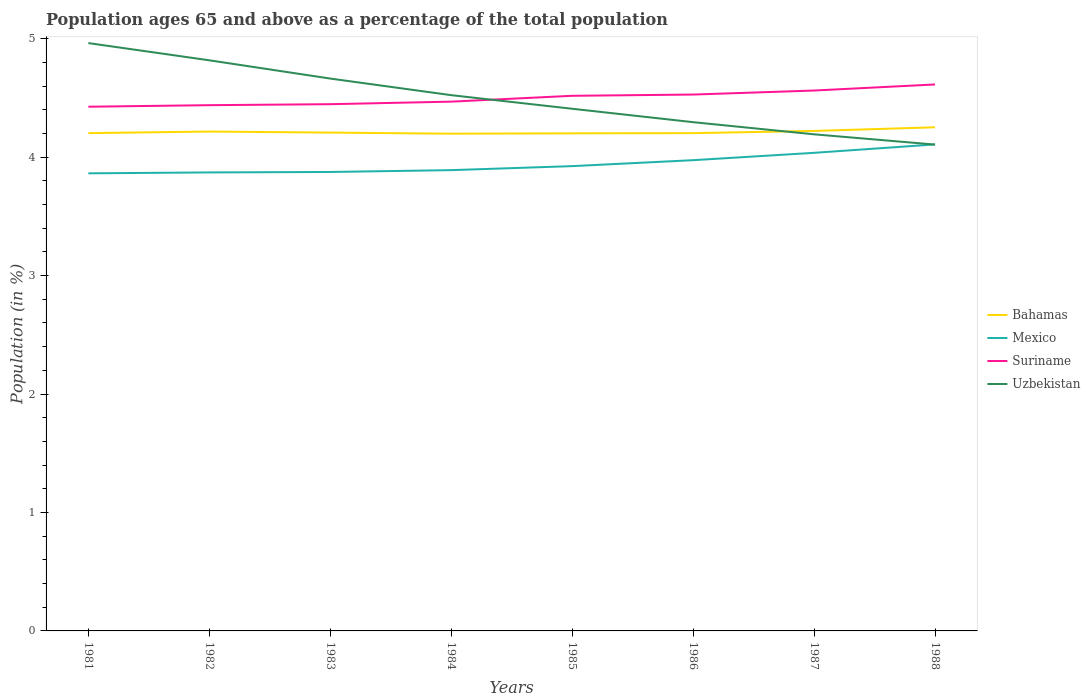How many different coloured lines are there?
Offer a very short reply. 4. Across all years, what is the maximum percentage of the population ages 65 and above in Uzbekistan?
Make the answer very short. 4.11. What is the total percentage of the population ages 65 and above in Uzbekistan in the graph?
Offer a very short reply. 0.71. What is the difference between the highest and the second highest percentage of the population ages 65 and above in Bahamas?
Your answer should be very brief. 0.05. What is the difference between the highest and the lowest percentage of the population ages 65 and above in Uzbekistan?
Keep it short and to the point. 4. Is the percentage of the population ages 65 and above in Bahamas strictly greater than the percentage of the population ages 65 and above in Uzbekistan over the years?
Your answer should be compact. No. How many lines are there?
Ensure brevity in your answer.  4. How many years are there in the graph?
Provide a succinct answer. 8. Does the graph contain any zero values?
Keep it short and to the point. No. Where does the legend appear in the graph?
Make the answer very short. Center right. How are the legend labels stacked?
Provide a succinct answer. Vertical. What is the title of the graph?
Offer a very short reply. Population ages 65 and above as a percentage of the total population. What is the label or title of the X-axis?
Provide a short and direct response. Years. What is the Population (in %) in Bahamas in 1981?
Your response must be concise. 4.2. What is the Population (in %) in Mexico in 1981?
Ensure brevity in your answer.  3.86. What is the Population (in %) in Suriname in 1981?
Offer a very short reply. 4.43. What is the Population (in %) of Uzbekistan in 1981?
Provide a short and direct response. 4.96. What is the Population (in %) in Bahamas in 1982?
Provide a short and direct response. 4.22. What is the Population (in %) of Mexico in 1982?
Offer a terse response. 3.87. What is the Population (in %) of Suriname in 1982?
Your answer should be compact. 4.44. What is the Population (in %) in Uzbekistan in 1982?
Offer a terse response. 4.82. What is the Population (in %) of Bahamas in 1983?
Provide a short and direct response. 4.21. What is the Population (in %) in Mexico in 1983?
Make the answer very short. 3.87. What is the Population (in %) in Suriname in 1983?
Your answer should be compact. 4.45. What is the Population (in %) in Uzbekistan in 1983?
Offer a terse response. 4.66. What is the Population (in %) in Bahamas in 1984?
Keep it short and to the point. 4.2. What is the Population (in %) of Mexico in 1984?
Offer a terse response. 3.89. What is the Population (in %) of Suriname in 1984?
Offer a very short reply. 4.47. What is the Population (in %) in Uzbekistan in 1984?
Keep it short and to the point. 4.52. What is the Population (in %) in Bahamas in 1985?
Provide a succinct answer. 4.2. What is the Population (in %) of Mexico in 1985?
Your response must be concise. 3.92. What is the Population (in %) in Suriname in 1985?
Ensure brevity in your answer.  4.52. What is the Population (in %) of Uzbekistan in 1985?
Make the answer very short. 4.41. What is the Population (in %) in Bahamas in 1986?
Your response must be concise. 4.2. What is the Population (in %) in Mexico in 1986?
Your answer should be very brief. 3.97. What is the Population (in %) of Suriname in 1986?
Your answer should be very brief. 4.53. What is the Population (in %) of Uzbekistan in 1986?
Make the answer very short. 4.29. What is the Population (in %) of Bahamas in 1987?
Offer a terse response. 4.22. What is the Population (in %) in Mexico in 1987?
Offer a very short reply. 4.04. What is the Population (in %) in Suriname in 1987?
Provide a short and direct response. 4.56. What is the Population (in %) in Uzbekistan in 1987?
Your answer should be very brief. 4.19. What is the Population (in %) of Bahamas in 1988?
Offer a terse response. 4.25. What is the Population (in %) in Mexico in 1988?
Provide a succinct answer. 4.11. What is the Population (in %) in Suriname in 1988?
Provide a succinct answer. 4.61. What is the Population (in %) of Uzbekistan in 1988?
Make the answer very short. 4.11. Across all years, what is the maximum Population (in %) in Bahamas?
Provide a succinct answer. 4.25. Across all years, what is the maximum Population (in %) of Mexico?
Provide a succinct answer. 4.11. Across all years, what is the maximum Population (in %) of Suriname?
Make the answer very short. 4.61. Across all years, what is the maximum Population (in %) in Uzbekistan?
Give a very brief answer. 4.96. Across all years, what is the minimum Population (in %) in Bahamas?
Give a very brief answer. 4.2. Across all years, what is the minimum Population (in %) of Mexico?
Offer a very short reply. 3.86. Across all years, what is the minimum Population (in %) in Suriname?
Offer a terse response. 4.43. Across all years, what is the minimum Population (in %) of Uzbekistan?
Offer a very short reply. 4.11. What is the total Population (in %) of Bahamas in the graph?
Your answer should be compact. 33.7. What is the total Population (in %) in Mexico in the graph?
Ensure brevity in your answer.  31.54. What is the total Population (in %) in Suriname in the graph?
Ensure brevity in your answer.  36. What is the total Population (in %) of Uzbekistan in the graph?
Your answer should be compact. 35.97. What is the difference between the Population (in %) in Bahamas in 1981 and that in 1982?
Give a very brief answer. -0.01. What is the difference between the Population (in %) in Mexico in 1981 and that in 1982?
Provide a succinct answer. -0.01. What is the difference between the Population (in %) in Suriname in 1981 and that in 1982?
Your answer should be very brief. -0.01. What is the difference between the Population (in %) in Uzbekistan in 1981 and that in 1982?
Your answer should be compact. 0.15. What is the difference between the Population (in %) of Bahamas in 1981 and that in 1983?
Your answer should be very brief. -0. What is the difference between the Population (in %) in Mexico in 1981 and that in 1983?
Make the answer very short. -0.01. What is the difference between the Population (in %) in Suriname in 1981 and that in 1983?
Ensure brevity in your answer.  -0.02. What is the difference between the Population (in %) of Uzbekistan in 1981 and that in 1983?
Your answer should be very brief. 0.3. What is the difference between the Population (in %) of Bahamas in 1981 and that in 1984?
Offer a terse response. 0. What is the difference between the Population (in %) in Mexico in 1981 and that in 1984?
Your response must be concise. -0.03. What is the difference between the Population (in %) in Suriname in 1981 and that in 1984?
Offer a very short reply. -0.04. What is the difference between the Population (in %) in Uzbekistan in 1981 and that in 1984?
Offer a terse response. 0.44. What is the difference between the Population (in %) of Bahamas in 1981 and that in 1985?
Offer a very short reply. 0. What is the difference between the Population (in %) in Mexico in 1981 and that in 1985?
Offer a very short reply. -0.06. What is the difference between the Population (in %) in Suriname in 1981 and that in 1985?
Your answer should be compact. -0.09. What is the difference between the Population (in %) in Uzbekistan in 1981 and that in 1985?
Provide a short and direct response. 0.55. What is the difference between the Population (in %) of Mexico in 1981 and that in 1986?
Offer a terse response. -0.11. What is the difference between the Population (in %) of Suriname in 1981 and that in 1986?
Keep it short and to the point. -0.1. What is the difference between the Population (in %) in Uzbekistan in 1981 and that in 1986?
Provide a short and direct response. 0.67. What is the difference between the Population (in %) of Bahamas in 1981 and that in 1987?
Keep it short and to the point. -0.02. What is the difference between the Population (in %) of Mexico in 1981 and that in 1987?
Keep it short and to the point. -0.17. What is the difference between the Population (in %) of Suriname in 1981 and that in 1987?
Your answer should be compact. -0.14. What is the difference between the Population (in %) in Uzbekistan in 1981 and that in 1987?
Your answer should be very brief. 0.77. What is the difference between the Population (in %) in Bahamas in 1981 and that in 1988?
Your answer should be compact. -0.05. What is the difference between the Population (in %) in Mexico in 1981 and that in 1988?
Your response must be concise. -0.24. What is the difference between the Population (in %) of Suriname in 1981 and that in 1988?
Ensure brevity in your answer.  -0.19. What is the difference between the Population (in %) in Uzbekistan in 1981 and that in 1988?
Provide a short and direct response. 0.86. What is the difference between the Population (in %) in Bahamas in 1982 and that in 1983?
Give a very brief answer. 0.01. What is the difference between the Population (in %) of Mexico in 1982 and that in 1983?
Ensure brevity in your answer.  -0. What is the difference between the Population (in %) of Suriname in 1982 and that in 1983?
Your response must be concise. -0.01. What is the difference between the Population (in %) of Uzbekistan in 1982 and that in 1983?
Offer a terse response. 0.15. What is the difference between the Population (in %) of Bahamas in 1982 and that in 1984?
Offer a terse response. 0.02. What is the difference between the Population (in %) of Mexico in 1982 and that in 1984?
Give a very brief answer. -0.02. What is the difference between the Population (in %) of Suriname in 1982 and that in 1984?
Your answer should be compact. -0.03. What is the difference between the Population (in %) of Uzbekistan in 1982 and that in 1984?
Offer a terse response. 0.29. What is the difference between the Population (in %) of Bahamas in 1982 and that in 1985?
Give a very brief answer. 0.02. What is the difference between the Population (in %) of Mexico in 1982 and that in 1985?
Give a very brief answer. -0.05. What is the difference between the Population (in %) of Suriname in 1982 and that in 1985?
Offer a terse response. -0.08. What is the difference between the Population (in %) in Uzbekistan in 1982 and that in 1985?
Your response must be concise. 0.41. What is the difference between the Population (in %) in Bahamas in 1982 and that in 1986?
Make the answer very short. 0.01. What is the difference between the Population (in %) in Mexico in 1982 and that in 1986?
Provide a succinct answer. -0.1. What is the difference between the Population (in %) in Suriname in 1982 and that in 1986?
Provide a short and direct response. -0.09. What is the difference between the Population (in %) of Uzbekistan in 1982 and that in 1986?
Your answer should be very brief. 0.52. What is the difference between the Population (in %) of Bahamas in 1982 and that in 1987?
Your answer should be very brief. -0.01. What is the difference between the Population (in %) in Mexico in 1982 and that in 1987?
Offer a very short reply. -0.17. What is the difference between the Population (in %) in Suriname in 1982 and that in 1987?
Your answer should be compact. -0.12. What is the difference between the Population (in %) in Uzbekistan in 1982 and that in 1987?
Your answer should be compact. 0.62. What is the difference between the Population (in %) in Bahamas in 1982 and that in 1988?
Your answer should be compact. -0.04. What is the difference between the Population (in %) of Mexico in 1982 and that in 1988?
Your response must be concise. -0.24. What is the difference between the Population (in %) of Suriname in 1982 and that in 1988?
Provide a succinct answer. -0.17. What is the difference between the Population (in %) of Uzbekistan in 1982 and that in 1988?
Ensure brevity in your answer.  0.71. What is the difference between the Population (in %) of Bahamas in 1983 and that in 1984?
Your answer should be compact. 0.01. What is the difference between the Population (in %) of Mexico in 1983 and that in 1984?
Offer a very short reply. -0.02. What is the difference between the Population (in %) of Suriname in 1983 and that in 1984?
Your answer should be very brief. -0.02. What is the difference between the Population (in %) in Uzbekistan in 1983 and that in 1984?
Offer a terse response. 0.14. What is the difference between the Population (in %) in Bahamas in 1983 and that in 1985?
Make the answer very short. 0.01. What is the difference between the Population (in %) in Mexico in 1983 and that in 1985?
Your response must be concise. -0.05. What is the difference between the Population (in %) of Suriname in 1983 and that in 1985?
Offer a terse response. -0.07. What is the difference between the Population (in %) of Uzbekistan in 1983 and that in 1985?
Your answer should be very brief. 0.25. What is the difference between the Population (in %) in Bahamas in 1983 and that in 1986?
Give a very brief answer. 0. What is the difference between the Population (in %) of Mexico in 1983 and that in 1986?
Your answer should be compact. -0.1. What is the difference between the Population (in %) of Suriname in 1983 and that in 1986?
Provide a succinct answer. -0.08. What is the difference between the Population (in %) of Uzbekistan in 1983 and that in 1986?
Provide a short and direct response. 0.37. What is the difference between the Population (in %) in Bahamas in 1983 and that in 1987?
Your response must be concise. -0.01. What is the difference between the Population (in %) in Mexico in 1983 and that in 1987?
Give a very brief answer. -0.16. What is the difference between the Population (in %) in Suriname in 1983 and that in 1987?
Give a very brief answer. -0.12. What is the difference between the Population (in %) in Uzbekistan in 1983 and that in 1987?
Offer a terse response. 0.47. What is the difference between the Population (in %) of Bahamas in 1983 and that in 1988?
Make the answer very short. -0.04. What is the difference between the Population (in %) of Mexico in 1983 and that in 1988?
Make the answer very short. -0.23. What is the difference between the Population (in %) in Suriname in 1983 and that in 1988?
Give a very brief answer. -0.17. What is the difference between the Population (in %) in Uzbekistan in 1983 and that in 1988?
Your answer should be compact. 0.56. What is the difference between the Population (in %) in Bahamas in 1984 and that in 1985?
Provide a succinct answer. -0. What is the difference between the Population (in %) of Mexico in 1984 and that in 1985?
Provide a short and direct response. -0.03. What is the difference between the Population (in %) of Suriname in 1984 and that in 1985?
Your answer should be compact. -0.05. What is the difference between the Population (in %) of Uzbekistan in 1984 and that in 1985?
Your answer should be compact. 0.11. What is the difference between the Population (in %) in Bahamas in 1984 and that in 1986?
Provide a succinct answer. -0. What is the difference between the Population (in %) in Mexico in 1984 and that in 1986?
Your response must be concise. -0.08. What is the difference between the Population (in %) of Suriname in 1984 and that in 1986?
Your response must be concise. -0.06. What is the difference between the Population (in %) in Uzbekistan in 1984 and that in 1986?
Offer a terse response. 0.23. What is the difference between the Population (in %) in Bahamas in 1984 and that in 1987?
Make the answer very short. -0.02. What is the difference between the Population (in %) of Mexico in 1984 and that in 1987?
Keep it short and to the point. -0.15. What is the difference between the Population (in %) of Suriname in 1984 and that in 1987?
Provide a short and direct response. -0.09. What is the difference between the Population (in %) in Uzbekistan in 1984 and that in 1987?
Provide a succinct answer. 0.33. What is the difference between the Population (in %) in Bahamas in 1984 and that in 1988?
Offer a very short reply. -0.05. What is the difference between the Population (in %) of Mexico in 1984 and that in 1988?
Provide a short and direct response. -0.22. What is the difference between the Population (in %) of Suriname in 1984 and that in 1988?
Provide a succinct answer. -0.15. What is the difference between the Population (in %) in Uzbekistan in 1984 and that in 1988?
Offer a very short reply. 0.42. What is the difference between the Population (in %) of Bahamas in 1985 and that in 1986?
Your answer should be very brief. -0. What is the difference between the Population (in %) of Mexico in 1985 and that in 1986?
Your answer should be very brief. -0.05. What is the difference between the Population (in %) of Suriname in 1985 and that in 1986?
Your response must be concise. -0.01. What is the difference between the Population (in %) in Uzbekistan in 1985 and that in 1986?
Offer a terse response. 0.11. What is the difference between the Population (in %) in Bahamas in 1985 and that in 1987?
Your response must be concise. -0.02. What is the difference between the Population (in %) in Mexico in 1985 and that in 1987?
Offer a terse response. -0.11. What is the difference between the Population (in %) in Suriname in 1985 and that in 1987?
Your response must be concise. -0.04. What is the difference between the Population (in %) in Uzbekistan in 1985 and that in 1987?
Offer a terse response. 0.22. What is the difference between the Population (in %) in Bahamas in 1985 and that in 1988?
Provide a short and direct response. -0.05. What is the difference between the Population (in %) in Mexico in 1985 and that in 1988?
Your answer should be very brief. -0.18. What is the difference between the Population (in %) of Suriname in 1985 and that in 1988?
Your answer should be compact. -0.1. What is the difference between the Population (in %) in Uzbekistan in 1985 and that in 1988?
Your response must be concise. 0.3. What is the difference between the Population (in %) in Bahamas in 1986 and that in 1987?
Ensure brevity in your answer.  -0.02. What is the difference between the Population (in %) in Mexico in 1986 and that in 1987?
Provide a succinct answer. -0.06. What is the difference between the Population (in %) of Suriname in 1986 and that in 1987?
Your answer should be compact. -0.03. What is the difference between the Population (in %) of Uzbekistan in 1986 and that in 1987?
Your answer should be compact. 0.1. What is the difference between the Population (in %) of Bahamas in 1986 and that in 1988?
Provide a short and direct response. -0.05. What is the difference between the Population (in %) in Mexico in 1986 and that in 1988?
Keep it short and to the point. -0.13. What is the difference between the Population (in %) of Suriname in 1986 and that in 1988?
Offer a terse response. -0.09. What is the difference between the Population (in %) in Uzbekistan in 1986 and that in 1988?
Provide a short and direct response. 0.19. What is the difference between the Population (in %) in Bahamas in 1987 and that in 1988?
Provide a short and direct response. -0.03. What is the difference between the Population (in %) in Mexico in 1987 and that in 1988?
Keep it short and to the point. -0.07. What is the difference between the Population (in %) in Suriname in 1987 and that in 1988?
Your answer should be very brief. -0.05. What is the difference between the Population (in %) of Uzbekistan in 1987 and that in 1988?
Provide a short and direct response. 0.09. What is the difference between the Population (in %) in Bahamas in 1981 and the Population (in %) in Mexico in 1982?
Offer a very short reply. 0.33. What is the difference between the Population (in %) in Bahamas in 1981 and the Population (in %) in Suriname in 1982?
Make the answer very short. -0.24. What is the difference between the Population (in %) of Bahamas in 1981 and the Population (in %) of Uzbekistan in 1982?
Offer a terse response. -0.61. What is the difference between the Population (in %) of Mexico in 1981 and the Population (in %) of Suriname in 1982?
Offer a very short reply. -0.58. What is the difference between the Population (in %) in Mexico in 1981 and the Population (in %) in Uzbekistan in 1982?
Offer a very short reply. -0.95. What is the difference between the Population (in %) of Suriname in 1981 and the Population (in %) of Uzbekistan in 1982?
Your response must be concise. -0.39. What is the difference between the Population (in %) in Bahamas in 1981 and the Population (in %) in Mexico in 1983?
Give a very brief answer. 0.33. What is the difference between the Population (in %) in Bahamas in 1981 and the Population (in %) in Suriname in 1983?
Your response must be concise. -0.24. What is the difference between the Population (in %) of Bahamas in 1981 and the Population (in %) of Uzbekistan in 1983?
Ensure brevity in your answer.  -0.46. What is the difference between the Population (in %) in Mexico in 1981 and the Population (in %) in Suriname in 1983?
Provide a short and direct response. -0.58. What is the difference between the Population (in %) of Mexico in 1981 and the Population (in %) of Uzbekistan in 1983?
Your answer should be very brief. -0.8. What is the difference between the Population (in %) in Suriname in 1981 and the Population (in %) in Uzbekistan in 1983?
Make the answer very short. -0.24. What is the difference between the Population (in %) in Bahamas in 1981 and the Population (in %) in Mexico in 1984?
Provide a succinct answer. 0.31. What is the difference between the Population (in %) in Bahamas in 1981 and the Population (in %) in Suriname in 1984?
Provide a succinct answer. -0.27. What is the difference between the Population (in %) in Bahamas in 1981 and the Population (in %) in Uzbekistan in 1984?
Your response must be concise. -0.32. What is the difference between the Population (in %) of Mexico in 1981 and the Population (in %) of Suriname in 1984?
Ensure brevity in your answer.  -0.61. What is the difference between the Population (in %) in Mexico in 1981 and the Population (in %) in Uzbekistan in 1984?
Provide a succinct answer. -0.66. What is the difference between the Population (in %) in Suriname in 1981 and the Population (in %) in Uzbekistan in 1984?
Your response must be concise. -0.1. What is the difference between the Population (in %) of Bahamas in 1981 and the Population (in %) of Mexico in 1985?
Provide a short and direct response. 0.28. What is the difference between the Population (in %) of Bahamas in 1981 and the Population (in %) of Suriname in 1985?
Give a very brief answer. -0.32. What is the difference between the Population (in %) in Bahamas in 1981 and the Population (in %) in Uzbekistan in 1985?
Ensure brevity in your answer.  -0.21. What is the difference between the Population (in %) of Mexico in 1981 and the Population (in %) of Suriname in 1985?
Provide a short and direct response. -0.65. What is the difference between the Population (in %) in Mexico in 1981 and the Population (in %) in Uzbekistan in 1985?
Give a very brief answer. -0.55. What is the difference between the Population (in %) in Suriname in 1981 and the Population (in %) in Uzbekistan in 1985?
Make the answer very short. 0.02. What is the difference between the Population (in %) of Bahamas in 1981 and the Population (in %) of Mexico in 1986?
Make the answer very short. 0.23. What is the difference between the Population (in %) of Bahamas in 1981 and the Population (in %) of Suriname in 1986?
Ensure brevity in your answer.  -0.33. What is the difference between the Population (in %) in Bahamas in 1981 and the Population (in %) in Uzbekistan in 1986?
Your response must be concise. -0.09. What is the difference between the Population (in %) in Mexico in 1981 and the Population (in %) in Suriname in 1986?
Offer a terse response. -0.67. What is the difference between the Population (in %) in Mexico in 1981 and the Population (in %) in Uzbekistan in 1986?
Offer a very short reply. -0.43. What is the difference between the Population (in %) of Suriname in 1981 and the Population (in %) of Uzbekistan in 1986?
Offer a terse response. 0.13. What is the difference between the Population (in %) of Bahamas in 1981 and the Population (in %) of Mexico in 1987?
Provide a short and direct response. 0.17. What is the difference between the Population (in %) in Bahamas in 1981 and the Population (in %) in Suriname in 1987?
Offer a very short reply. -0.36. What is the difference between the Population (in %) in Bahamas in 1981 and the Population (in %) in Uzbekistan in 1987?
Your answer should be compact. 0.01. What is the difference between the Population (in %) of Mexico in 1981 and the Population (in %) of Suriname in 1987?
Make the answer very short. -0.7. What is the difference between the Population (in %) in Mexico in 1981 and the Population (in %) in Uzbekistan in 1987?
Your response must be concise. -0.33. What is the difference between the Population (in %) of Suriname in 1981 and the Population (in %) of Uzbekistan in 1987?
Your answer should be very brief. 0.23. What is the difference between the Population (in %) of Bahamas in 1981 and the Population (in %) of Mexico in 1988?
Your response must be concise. 0.1. What is the difference between the Population (in %) in Bahamas in 1981 and the Population (in %) in Suriname in 1988?
Keep it short and to the point. -0.41. What is the difference between the Population (in %) of Bahamas in 1981 and the Population (in %) of Uzbekistan in 1988?
Keep it short and to the point. 0.1. What is the difference between the Population (in %) in Mexico in 1981 and the Population (in %) in Suriname in 1988?
Your answer should be compact. -0.75. What is the difference between the Population (in %) of Mexico in 1981 and the Population (in %) of Uzbekistan in 1988?
Keep it short and to the point. -0.24. What is the difference between the Population (in %) in Suriname in 1981 and the Population (in %) in Uzbekistan in 1988?
Offer a very short reply. 0.32. What is the difference between the Population (in %) of Bahamas in 1982 and the Population (in %) of Mexico in 1983?
Provide a succinct answer. 0.34. What is the difference between the Population (in %) in Bahamas in 1982 and the Population (in %) in Suriname in 1983?
Provide a short and direct response. -0.23. What is the difference between the Population (in %) of Bahamas in 1982 and the Population (in %) of Uzbekistan in 1983?
Offer a very short reply. -0.45. What is the difference between the Population (in %) in Mexico in 1982 and the Population (in %) in Suriname in 1983?
Your response must be concise. -0.58. What is the difference between the Population (in %) of Mexico in 1982 and the Population (in %) of Uzbekistan in 1983?
Your answer should be compact. -0.79. What is the difference between the Population (in %) in Suriname in 1982 and the Population (in %) in Uzbekistan in 1983?
Offer a very short reply. -0.22. What is the difference between the Population (in %) in Bahamas in 1982 and the Population (in %) in Mexico in 1984?
Your answer should be very brief. 0.33. What is the difference between the Population (in %) of Bahamas in 1982 and the Population (in %) of Suriname in 1984?
Ensure brevity in your answer.  -0.25. What is the difference between the Population (in %) of Bahamas in 1982 and the Population (in %) of Uzbekistan in 1984?
Provide a short and direct response. -0.31. What is the difference between the Population (in %) in Mexico in 1982 and the Population (in %) in Suriname in 1984?
Ensure brevity in your answer.  -0.6. What is the difference between the Population (in %) of Mexico in 1982 and the Population (in %) of Uzbekistan in 1984?
Offer a terse response. -0.65. What is the difference between the Population (in %) in Suriname in 1982 and the Population (in %) in Uzbekistan in 1984?
Give a very brief answer. -0.08. What is the difference between the Population (in %) in Bahamas in 1982 and the Population (in %) in Mexico in 1985?
Give a very brief answer. 0.29. What is the difference between the Population (in %) of Bahamas in 1982 and the Population (in %) of Suriname in 1985?
Ensure brevity in your answer.  -0.3. What is the difference between the Population (in %) in Bahamas in 1982 and the Population (in %) in Uzbekistan in 1985?
Offer a very short reply. -0.19. What is the difference between the Population (in %) in Mexico in 1982 and the Population (in %) in Suriname in 1985?
Provide a short and direct response. -0.65. What is the difference between the Population (in %) of Mexico in 1982 and the Population (in %) of Uzbekistan in 1985?
Offer a very short reply. -0.54. What is the difference between the Population (in %) of Suriname in 1982 and the Population (in %) of Uzbekistan in 1985?
Make the answer very short. 0.03. What is the difference between the Population (in %) of Bahamas in 1982 and the Population (in %) of Mexico in 1986?
Offer a very short reply. 0.24. What is the difference between the Population (in %) in Bahamas in 1982 and the Population (in %) in Suriname in 1986?
Offer a very short reply. -0.31. What is the difference between the Population (in %) of Bahamas in 1982 and the Population (in %) of Uzbekistan in 1986?
Give a very brief answer. -0.08. What is the difference between the Population (in %) in Mexico in 1982 and the Population (in %) in Suriname in 1986?
Give a very brief answer. -0.66. What is the difference between the Population (in %) in Mexico in 1982 and the Population (in %) in Uzbekistan in 1986?
Offer a very short reply. -0.42. What is the difference between the Population (in %) in Suriname in 1982 and the Population (in %) in Uzbekistan in 1986?
Provide a succinct answer. 0.14. What is the difference between the Population (in %) in Bahamas in 1982 and the Population (in %) in Mexico in 1987?
Provide a short and direct response. 0.18. What is the difference between the Population (in %) of Bahamas in 1982 and the Population (in %) of Suriname in 1987?
Your response must be concise. -0.35. What is the difference between the Population (in %) in Bahamas in 1982 and the Population (in %) in Uzbekistan in 1987?
Ensure brevity in your answer.  0.02. What is the difference between the Population (in %) in Mexico in 1982 and the Population (in %) in Suriname in 1987?
Offer a terse response. -0.69. What is the difference between the Population (in %) in Mexico in 1982 and the Population (in %) in Uzbekistan in 1987?
Offer a terse response. -0.32. What is the difference between the Population (in %) of Suriname in 1982 and the Population (in %) of Uzbekistan in 1987?
Make the answer very short. 0.25. What is the difference between the Population (in %) of Bahamas in 1982 and the Population (in %) of Mexico in 1988?
Give a very brief answer. 0.11. What is the difference between the Population (in %) of Bahamas in 1982 and the Population (in %) of Suriname in 1988?
Make the answer very short. -0.4. What is the difference between the Population (in %) in Bahamas in 1982 and the Population (in %) in Uzbekistan in 1988?
Your answer should be compact. 0.11. What is the difference between the Population (in %) of Mexico in 1982 and the Population (in %) of Suriname in 1988?
Your answer should be compact. -0.74. What is the difference between the Population (in %) in Mexico in 1982 and the Population (in %) in Uzbekistan in 1988?
Provide a short and direct response. -0.23. What is the difference between the Population (in %) in Suriname in 1982 and the Population (in %) in Uzbekistan in 1988?
Make the answer very short. 0.33. What is the difference between the Population (in %) of Bahamas in 1983 and the Population (in %) of Mexico in 1984?
Ensure brevity in your answer.  0.32. What is the difference between the Population (in %) in Bahamas in 1983 and the Population (in %) in Suriname in 1984?
Keep it short and to the point. -0.26. What is the difference between the Population (in %) in Bahamas in 1983 and the Population (in %) in Uzbekistan in 1984?
Ensure brevity in your answer.  -0.32. What is the difference between the Population (in %) in Mexico in 1983 and the Population (in %) in Suriname in 1984?
Your response must be concise. -0.59. What is the difference between the Population (in %) of Mexico in 1983 and the Population (in %) of Uzbekistan in 1984?
Ensure brevity in your answer.  -0.65. What is the difference between the Population (in %) of Suriname in 1983 and the Population (in %) of Uzbekistan in 1984?
Your answer should be compact. -0.08. What is the difference between the Population (in %) in Bahamas in 1983 and the Population (in %) in Mexico in 1985?
Provide a short and direct response. 0.28. What is the difference between the Population (in %) of Bahamas in 1983 and the Population (in %) of Suriname in 1985?
Offer a very short reply. -0.31. What is the difference between the Population (in %) in Bahamas in 1983 and the Population (in %) in Uzbekistan in 1985?
Give a very brief answer. -0.2. What is the difference between the Population (in %) of Mexico in 1983 and the Population (in %) of Suriname in 1985?
Offer a terse response. -0.64. What is the difference between the Population (in %) of Mexico in 1983 and the Population (in %) of Uzbekistan in 1985?
Your response must be concise. -0.53. What is the difference between the Population (in %) in Suriname in 1983 and the Population (in %) in Uzbekistan in 1985?
Provide a succinct answer. 0.04. What is the difference between the Population (in %) of Bahamas in 1983 and the Population (in %) of Mexico in 1986?
Your answer should be compact. 0.23. What is the difference between the Population (in %) in Bahamas in 1983 and the Population (in %) in Suriname in 1986?
Your answer should be compact. -0.32. What is the difference between the Population (in %) of Bahamas in 1983 and the Population (in %) of Uzbekistan in 1986?
Make the answer very short. -0.09. What is the difference between the Population (in %) in Mexico in 1983 and the Population (in %) in Suriname in 1986?
Your response must be concise. -0.65. What is the difference between the Population (in %) in Mexico in 1983 and the Population (in %) in Uzbekistan in 1986?
Give a very brief answer. -0.42. What is the difference between the Population (in %) in Suriname in 1983 and the Population (in %) in Uzbekistan in 1986?
Your response must be concise. 0.15. What is the difference between the Population (in %) in Bahamas in 1983 and the Population (in %) in Mexico in 1987?
Your answer should be compact. 0.17. What is the difference between the Population (in %) in Bahamas in 1983 and the Population (in %) in Suriname in 1987?
Give a very brief answer. -0.36. What is the difference between the Population (in %) in Bahamas in 1983 and the Population (in %) in Uzbekistan in 1987?
Offer a very short reply. 0.01. What is the difference between the Population (in %) of Mexico in 1983 and the Population (in %) of Suriname in 1987?
Offer a terse response. -0.69. What is the difference between the Population (in %) in Mexico in 1983 and the Population (in %) in Uzbekistan in 1987?
Ensure brevity in your answer.  -0.32. What is the difference between the Population (in %) in Suriname in 1983 and the Population (in %) in Uzbekistan in 1987?
Make the answer very short. 0.25. What is the difference between the Population (in %) of Bahamas in 1983 and the Population (in %) of Mexico in 1988?
Offer a very short reply. 0.1. What is the difference between the Population (in %) of Bahamas in 1983 and the Population (in %) of Suriname in 1988?
Give a very brief answer. -0.41. What is the difference between the Population (in %) in Bahamas in 1983 and the Population (in %) in Uzbekistan in 1988?
Offer a very short reply. 0.1. What is the difference between the Population (in %) of Mexico in 1983 and the Population (in %) of Suriname in 1988?
Your response must be concise. -0.74. What is the difference between the Population (in %) of Mexico in 1983 and the Population (in %) of Uzbekistan in 1988?
Give a very brief answer. -0.23. What is the difference between the Population (in %) of Suriname in 1983 and the Population (in %) of Uzbekistan in 1988?
Your response must be concise. 0.34. What is the difference between the Population (in %) of Bahamas in 1984 and the Population (in %) of Mexico in 1985?
Your answer should be very brief. 0.27. What is the difference between the Population (in %) in Bahamas in 1984 and the Population (in %) in Suriname in 1985?
Keep it short and to the point. -0.32. What is the difference between the Population (in %) in Bahamas in 1984 and the Population (in %) in Uzbekistan in 1985?
Ensure brevity in your answer.  -0.21. What is the difference between the Population (in %) of Mexico in 1984 and the Population (in %) of Suriname in 1985?
Your response must be concise. -0.63. What is the difference between the Population (in %) of Mexico in 1984 and the Population (in %) of Uzbekistan in 1985?
Keep it short and to the point. -0.52. What is the difference between the Population (in %) of Suriname in 1984 and the Population (in %) of Uzbekistan in 1985?
Ensure brevity in your answer.  0.06. What is the difference between the Population (in %) in Bahamas in 1984 and the Population (in %) in Mexico in 1986?
Give a very brief answer. 0.22. What is the difference between the Population (in %) in Bahamas in 1984 and the Population (in %) in Suriname in 1986?
Offer a terse response. -0.33. What is the difference between the Population (in %) in Bahamas in 1984 and the Population (in %) in Uzbekistan in 1986?
Keep it short and to the point. -0.1. What is the difference between the Population (in %) in Mexico in 1984 and the Population (in %) in Suriname in 1986?
Your answer should be compact. -0.64. What is the difference between the Population (in %) of Mexico in 1984 and the Population (in %) of Uzbekistan in 1986?
Keep it short and to the point. -0.41. What is the difference between the Population (in %) of Suriname in 1984 and the Population (in %) of Uzbekistan in 1986?
Provide a succinct answer. 0.17. What is the difference between the Population (in %) of Bahamas in 1984 and the Population (in %) of Mexico in 1987?
Ensure brevity in your answer.  0.16. What is the difference between the Population (in %) in Bahamas in 1984 and the Population (in %) in Suriname in 1987?
Your response must be concise. -0.36. What is the difference between the Population (in %) in Bahamas in 1984 and the Population (in %) in Uzbekistan in 1987?
Your answer should be very brief. 0.01. What is the difference between the Population (in %) in Mexico in 1984 and the Population (in %) in Suriname in 1987?
Your answer should be compact. -0.67. What is the difference between the Population (in %) in Mexico in 1984 and the Population (in %) in Uzbekistan in 1987?
Your response must be concise. -0.3. What is the difference between the Population (in %) in Suriname in 1984 and the Population (in %) in Uzbekistan in 1987?
Give a very brief answer. 0.28. What is the difference between the Population (in %) in Bahamas in 1984 and the Population (in %) in Mexico in 1988?
Provide a succinct answer. 0.09. What is the difference between the Population (in %) in Bahamas in 1984 and the Population (in %) in Suriname in 1988?
Offer a terse response. -0.42. What is the difference between the Population (in %) in Bahamas in 1984 and the Population (in %) in Uzbekistan in 1988?
Offer a very short reply. 0.09. What is the difference between the Population (in %) of Mexico in 1984 and the Population (in %) of Suriname in 1988?
Keep it short and to the point. -0.72. What is the difference between the Population (in %) of Mexico in 1984 and the Population (in %) of Uzbekistan in 1988?
Your answer should be compact. -0.22. What is the difference between the Population (in %) of Suriname in 1984 and the Population (in %) of Uzbekistan in 1988?
Keep it short and to the point. 0.36. What is the difference between the Population (in %) in Bahamas in 1985 and the Population (in %) in Mexico in 1986?
Ensure brevity in your answer.  0.23. What is the difference between the Population (in %) in Bahamas in 1985 and the Population (in %) in Suriname in 1986?
Offer a terse response. -0.33. What is the difference between the Population (in %) in Bahamas in 1985 and the Population (in %) in Uzbekistan in 1986?
Offer a very short reply. -0.09. What is the difference between the Population (in %) in Mexico in 1985 and the Population (in %) in Suriname in 1986?
Your response must be concise. -0.6. What is the difference between the Population (in %) of Mexico in 1985 and the Population (in %) of Uzbekistan in 1986?
Your response must be concise. -0.37. What is the difference between the Population (in %) of Suriname in 1985 and the Population (in %) of Uzbekistan in 1986?
Your answer should be very brief. 0.22. What is the difference between the Population (in %) in Bahamas in 1985 and the Population (in %) in Mexico in 1987?
Your answer should be compact. 0.16. What is the difference between the Population (in %) of Bahamas in 1985 and the Population (in %) of Suriname in 1987?
Make the answer very short. -0.36. What is the difference between the Population (in %) of Bahamas in 1985 and the Population (in %) of Uzbekistan in 1987?
Your answer should be compact. 0.01. What is the difference between the Population (in %) in Mexico in 1985 and the Population (in %) in Suriname in 1987?
Your response must be concise. -0.64. What is the difference between the Population (in %) of Mexico in 1985 and the Population (in %) of Uzbekistan in 1987?
Offer a terse response. -0.27. What is the difference between the Population (in %) of Suriname in 1985 and the Population (in %) of Uzbekistan in 1987?
Offer a very short reply. 0.33. What is the difference between the Population (in %) in Bahamas in 1985 and the Population (in %) in Mexico in 1988?
Offer a terse response. 0.09. What is the difference between the Population (in %) in Bahamas in 1985 and the Population (in %) in Suriname in 1988?
Provide a short and direct response. -0.41. What is the difference between the Population (in %) in Bahamas in 1985 and the Population (in %) in Uzbekistan in 1988?
Keep it short and to the point. 0.1. What is the difference between the Population (in %) of Mexico in 1985 and the Population (in %) of Suriname in 1988?
Offer a very short reply. -0.69. What is the difference between the Population (in %) in Mexico in 1985 and the Population (in %) in Uzbekistan in 1988?
Your response must be concise. -0.18. What is the difference between the Population (in %) in Suriname in 1985 and the Population (in %) in Uzbekistan in 1988?
Provide a succinct answer. 0.41. What is the difference between the Population (in %) of Bahamas in 1986 and the Population (in %) of Mexico in 1987?
Provide a succinct answer. 0.17. What is the difference between the Population (in %) in Bahamas in 1986 and the Population (in %) in Suriname in 1987?
Your response must be concise. -0.36. What is the difference between the Population (in %) of Mexico in 1986 and the Population (in %) of Suriname in 1987?
Your response must be concise. -0.59. What is the difference between the Population (in %) of Mexico in 1986 and the Population (in %) of Uzbekistan in 1987?
Your response must be concise. -0.22. What is the difference between the Population (in %) of Suriname in 1986 and the Population (in %) of Uzbekistan in 1987?
Ensure brevity in your answer.  0.34. What is the difference between the Population (in %) in Bahamas in 1986 and the Population (in %) in Mexico in 1988?
Ensure brevity in your answer.  0.1. What is the difference between the Population (in %) in Bahamas in 1986 and the Population (in %) in Suriname in 1988?
Make the answer very short. -0.41. What is the difference between the Population (in %) in Bahamas in 1986 and the Population (in %) in Uzbekistan in 1988?
Your response must be concise. 0.1. What is the difference between the Population (in %) in Mexico in 1986 and the Population (in %) in Suriname in 1988?
Provide a succinct answer. -0.64. What is the difference between the Population (in %) of Mexico in 1986 and the Population (in %) of Uzbekistan in 1988?
Give a very brief answer. -0.13. What is the difference between the Population (in %) in Suriname in 1986 and the Population (in %) in Uzbekistan in 1988?
Offer a terse response. 0.42. What is the difference between the Population (in %) of Bahamas in 1987 and the Population (in %) of Mexico in 1988?
Make the answer very short. 0.11. What is the difference between the Population (in %) in Bahamas in 1987 and the Population (in %) in Suriname in 1988?
Offer a very short reply. -0.39. What is the difference between the Population (in %) in Bahamas in 1987 and the Population (in %) in Uzbekistan in 1988?
Your answer should be very brief. 0.12. What is the difference between the Population (in %) of Mexico in 1987 and the Population (in %) of Suriname in 1988?
Your response must be concise. -0.58. What is the difference between the Population (in %) of Mexico in 1987 and the Population (in %) of Uzbekistan in 1988?
Provide a short and direct response. -0.07. What is the difference between the Population (in %) of Suriname in 1987 and the Population (in %) of Uzbekistan in 1988?
Your answer should be very brief. 0.46. What is the average Population (in %) of Bahamas per year?
Give a very brief answer. 4.21. What is the average Population (in %) in Mexico per year?
Provide a short and direct response. 3.94. What is the average Population (in %) in Suriname per year?
Offer a terse response. 4.5. What is the average Population (in %) of Uzbekistan per year?
Give a very brief answer. 4.5. In the year 1981, what is the difference between the Population (in %) of Bahamas and Population (in %) of Mexico?
Give a very brief answer. 0.34. In the year 1981, what is the difference between the Population (in %) in Bahamas and Population (in %) in Suriname?
Provide a succinct answer. -0.22. In the year 1981, what is the difference between the Population (in %) in Bahamas and Population (in %) in Uzbekistan?
Offer a terse response. -0.76. In the year 1981, what is the difference between the Population (in %) of Mexico and Population (in %) of Suriname?
Offer a terse response. -0.56. In the year 1981, what is the difference between the Population (in %) in Mexico and Population (in %) in Uzbekistan?
Offer a very short reply. -1.1. In the year 1981, what is the difference between the Population (in %) in Suriname and Population (in %) in Uzbekistan?
Offer a terse response. -0.54. In the year 1982, what is the difference between the Population (in %) in Bahamas and Population (in %) in Mexico?
Offer a very short reply. 0.35. In the year 1982, what is the difference between the Population (in %) of Bahamas and Population (in %) of Suriname?
Your response must be concise. -0.22. In the year 1982, what is the difference between the Population (in %) in Bahamas and Population (in %) in Uzbekistan?
Your response must be concise. -0.6. In the year 1982, what is the difference between the Population (in %) in Mexico and Population (in %) in Suriname?
Offer a terse response. -0.57. In the year 1982, what is the difference between the Population (in %) in Mexico and Population (in %) in Uzbekistan?
Offer a very short reply. -0.95. In the year 1982, what is the difference between the Population (in %) of Suriname and Population (in %) of Uzbekistan?
Ensure brevity in your answer.  -0.38. In the year 1983, what is the difference between the Population (in %) of Bahamas and Population (in %) of Mexico?
Your answer should be very brief. 0.33. In the year 1983, what is the difference between the Population (in %) of Bahamas and Population (in %) of Suriname?
Offer a terse response. -0.24. In the year 1983, what is the difference between the Population (in %) in Bahamas and Population (in %) in Uzbekistan?
Your answer should be compact. -0.46. In the year 1983, what is the difference between the Population (in %) of Mexico and Population (in %) of Suriname?
Offer a very short reply. -0.57. In the year 1983, what is the difference between the Population (in %) of Mexico and Population (in %) of Uzbekistan?
Provide a short and direct response. -0.79. In the year 1983, what is the difference between the Population (in %) in Suriname and Population (in %) in Uzbekistan?
Provide a succinct answer. -0.22. In the year 1984, what is the difference between the Population (in %) of Bahamas and Population (in %) of Mexico?
Ensure brevity in your answer.  0.31. In the year 1984, what is the difference between the Population (in %) of Bahamas and Population (in %) of Suriname?
Keep it short and to the point. -0.27. In the year 1984, what is the difference between the Population (in %) of Bahamas and Population (in %) of Uzbekistan?
Provide a succinct answer. -0.33. In the year 1984, what is the difference between the Population (in %) in Mexico and Population (in %) in Suriname?
Your response must be concise. -0.58. In the year 1984, what is the difference between the Population (in %) in Mexico and Population (in %) in Uzbekistan?
Make the answer very short. -0.63. In the year 1984, what is the difference between the Population (in %) in Suriname and Population (in %) in Uzbekistan?
Your response must be concise. -0.05. In the year 1985, what is the difference between the Population (in %) in Bahamas and Population (in %) in Mexico?
Ensure brevity in your answer.  0.28. In the year 1985, what is the difference between the Population (in %) of Bahamas and Population (in %) of Suriname?
Ensure brevity in your answer.  -0.32. In the year 1985, what is the difference between the Population (in %) in Bahamas and Population (in %) in Uzbekistan?
Your response must be concise. -0.21. In the year 1985, what is the difference between the Population (in %) in Mexico and Population (in %) in Suriname?
Your answer should be compact. -0.59. In the year 1985, what is the difference between the Population (in %) of Mexico and Population (in %) of Uzbekistan?
Provide a succinct answer. -0.48. In the year 1985, what is the difference between the Population (in %) in Suriname and Population (in %) in Uzbekistan?
Keep it short and to the point. 0.11. In the year 1986, what is the difference between the Population (in %) of Bahamas and Population (in %) of Mexico?
Offer a terse response. 0.23. In the year 1986, what is the difference between the Population (in %) of Bahamas and Population (in %) of Suriname?
Make the answer very short. -0.33. In the year 1986, what is the difference between the Population (in %) of Bahamas and Population (in %) of Uzbekistan?
Provide a short and direct response. -0.09. In the year 1986, what is the difference between the Population (in %) of Mexico and Population (in %) of Suriname?
Provide a succinct answer. -0.55. In the year 1986, what is the difference between the Population (in %) of Mexico and Population (in %) of Uzbekistan?
Your answer should be compact. -0.32. In the year 1986, what is the difference between the Population (in %) in Suriname and Population (in %) in Uzbekistan?
Offer a terse response. 0.23. In the year 1987, what is the difference between the Population (in %) in Bahamas and Population (in %) in Mexico?
Give a very brief answer. 0.18. In the year 1987, what is the difference between the Population (in %) of Bahamas and Population (in %) of Suriname?
Give a very brief answer. -0.34. In the year 1987, what is the difference between the Population (in %) in Bahamas and Population (in %) in Uzbekistan?
Your answer should be very brief. 0.03. In the year 1987, what is the difference between the Population (in %) of Mexico and Population (in %) of Suriname?
Ensure brevity in your answer.  -0.53. In the year 1987, what is the difference between the Population (in %) in Mexico and Population (in %) in Uzbekistan?
Offer a terse response. -0.16. In the year 1987, what is the difference between the Population (in %) in Suriname and Population (in %) in Uzbekistan?
Keep it short and to the point. 0.37. In the year 1988, what is the difference between the Population (in %) of Bahamas and Population (in %) of Mexico?
Offer a terse response. 0.14. In the year 1988, what is the difference between the Population (in %) of Bahamas and Population (in %) of Suriname?
Your answer should be compact. -0.36. In the year 1988, what is the difference between the Population (in %) in Bahamas and Population (in %) in Uzbekistan?
Your response must be concise. 0.15. In the year 1988, what is the difference between the Population (in %) in Mexico and Population (in %) in Suriname?
Provide a succinct answer. -0.51. In the year 1988, what is the difference between the Population (in %) of Mexico and Population (in %) of Uzbekistan?
Provide a short and direct response. 0. In the year 1988, what is the difference between the Population (in %) in Suriname and Population (in %) in Uzbekistan?
Offer a very short reply. 0.51. What is the ratio of the Population (in %) of Uzbekistan in 1981 to that in 1982?
Give a very brief answer. 1.03. What is the ratio of the Population (in %) of Bahamas in 1981 to that in 1983?
Ensure brevity in your answer.  1. What is the ratio of the Population (in %) of Uzbekistan in 1981 to that in 1983?
Your answer should be very brief. 1.06. What is the ratio of the Population (in %) in Suriname in 1981 to that in 1984?
Give a very brief answer. 0.99. What is the ratio of the Population (in %) in Uzbekistan in 1981 to that in 1984?
Your answer should be compact. 1.1. What is the ratio of the Population (in %) in Bahamas in 1981 to that in 1985?
Give a very brief answer. 1. What is the ratio of the Population (in %) in Mexico in 1981 to that in 1985?
Ensure brevity in your answer.  0.98. What is the ratio of the Population (in %) of Suriname in 1981 to that in 1985?
Your answer should be compact. 0.98. What is the ratio of the Population (in %) of Uzbekistan in 1981 to that in 1985?
Your answer should be very brief. 1.13. What is the ratio of the Population (in %) of Bahamas in 1981 to that in 1986?
Ensure brevity in your answer.  1. What is the ratio of the Population (in %) of Mexico in 1981 to that in 1986?
Your response must be concise. 0.97. What is the ratio of the Population (in %) in Suriname in 1981 to that in 1986?
Your answer should be very brief. 0.98. What is the ratio of the Population (in %) of Uzbekistan in 1981 to that in 1986?
Ensure brevity in your answer.  1.16. What is the ratio of the Population (in %) of Mexico in 1981 to that in 1987?
Give a very brief answer. 0.96. What is the ratio of the Population (in %) in Uzbekistan in 1981 to that in 1987?
Provide a short and direct response. 1.18. What is the ratio of the Population (in %) in Bahamas in 1981 to that in 1988?
Your response must be concise. 0.99. What is the ratio of the Population (in %) in Mexico in 1981 to that in 1988?
Your answer should be compact. 0.94. What is the ratio of the Population (in %) of Suriname in 1981 to that in 1988?
Ensure brevity in your answer.  0.96. What is the ratio of the Population (in %) in Uzbekistan in 1981 to that in 1988?
Your response must be concise. 1.21. What is the ratio of the Population (in %) in Bahamas in 1982 to that in 1983?
Ensure brevity in your answer.  1. What is the ratio of the Population (in %) in Mexico in 1982 to that in 1983?
Offer a terse response. 1. What is the ratio of the Population (in %) in Suriname in 1982 to that in 1983?
Provide a short and direct response. 1. What is the ratio of the Population (in %) of Uzbekistan in 1982 to that in 1983?
Your answer should be compact. 1.03. What is the ratio of the Population (in %) in Bahamas in 1982 to that in 1984?
Offer a very short reply. 1. What is the ratio of the Population (in %) of Mexico in 1982 to that in 1984?
Offer a very short reply. 1. What is the ratio of the Population (in %) in Suriname in 1982 to that in 1984?
Your response must be concise. 0.99. What is the ratio of the Population (in %) in Uzbekistan in 1982 to that in 1984?
Ensure brevity in your answer.  1.07. What is the ratio of the Population (in %) of Mexico in 1982 to that in 1985?
Your answer should be very brief. 0.99. What is the ratio of the Population (in %) of Suriname in 1982 to that in 1985?
Give a very brief answer. 0.98. What is the ratio of the Population (in %) of Uzbekistan in 1982 to that in 1985?
Offer a terse response. 1.09. What is the ratio of the Population (in %) of Mexico in 1982 to that in 1986?
Your answer should be very brief. 0.97. What is the ratio of the Population (in %) of Suriname in 1982 to that in 1986?
Offer a terse response. 0.98. What is the ratio of the Population (in %) in Uzbekistan in 1982 to that in 1986?
Ensure brevity in your answer.  1.12. What is the ratio of the Population (in %) in Bahamas in 1982 to that in 1987?
Give a very brief answer. 1. What is the ratio of the Population (in %) of Suriname in 1982 to that in 1987?
Give a very brief answer. 0.97. What is the ratio of the Population (in %) of Uzbekistan in 1982 to that in 1987?
Your answer should be compact. 1.15. What is the ratio of the Population (in %) in Mexico in 1982 to that in 1988?
Your answer should be compact. 0.94. What is the ratio of the Population (in %) of Suriname in 1982 to that in 1988?
Make the answer very short. 0.96. What is the ratio of the Population (in %) in Uzbekistan in 1982 to that in 1988?
Your answer should be very brief. 1.17. What is the ratio of the Population (in %) of Mexico in 1983 to that in 1984?
Offer a terse response. 1. What is the ratio of the Population (in %) of Uzbekistan in 1983 to that in 1984?
Your answer should be very brief. 1.03. What is the ratio of the Population (in %) in Mexico in 1983 to that in 1985?
Offer a terse response. 0.99. What is the ratio of the Population (in %) of Suriname in 1983 to that in 1985?
Your response must be concise. 0.98. What is the ratio of the Population (in %) of Uzbekistan in 1983 to that in 1985?
Provide a short and direct response. 1.06. What is the ratio of the Population (in %) in Mexico in 1983 to that in 1986?
Offer a terse response. 0.97. What is the ratio of the Population (in %) in Suriname in 1983 to that in 1986?
Your response must be concise. 0.98. What is the ratio of the Population (in %) of Uzbekistan in 1983 to that in 1986?
Your answer should be very brief. 1.09. What is the ratio of the Population (in %) in Bahamas in 1983 to that in 1987?
Your answer should be very brief. 1. What is the ratio of the Population (in %) of Mexico in 1983 to that in 1987?
Offer a very short reply. 0.96. What is the ratio of the Population (in %) of Suriname in 1983 to that in 1987?
Offer a terse response. 0.97. What is the ratio of the Population (in %) of Uzbekistan in 1983 to that in 1987?
Offer a very short reply. 1.11. What is the ratio of the Population (in %) of Bahamas in 1983 to that in 1988?
Your answer should be very brief. 0.99. What is the ratio of the Population (in %) in Mexico in 1983 to that in 1988?
Your answer should be compact. 0.94. What is the ratio of the Population (in %) in Suriname in 1983 to that in 1988?
Make the answer very short. 0.96. What is the ratio of the Population (in %) of Uzbekistan in 1983 to that in 1988?
Provide a short and direct response. 1.14. What is the ratio of the Population (in %) of Mexico in 1984 to that in 1985?
Keep it short and to the point. 0.99. What is the ratio of the Population (in %) of Suriname in 1984 to that in 1985?
Keep it short and to the point. 0.99. What is the ratio of the Population (in %) of Uzbekistan in 1984 to that in 1985?
Provide a succinct answer. 1.03. What is the ratio of the Population (in %) of Bahamas in 1984 to that in 1986?
Give a very brief answer. 1. What is the ratio of the Population (in %) of Mexico in 1984 to that in 1986?
Provide a succinct answer. 0.98. What is the ratio of the Population (in %) of Suriname in 1984 to that in 1986?
Provide a succinct answer. 0.99. What is the ratio of the Population (in %) of Uzbekistan in 1984 to that in 1986?
Make the answer very short. 1.05. What is the ratio of the Population (in %) of Bahamas in 1984 to that in 1987?
Provide a short and direct response. 0.99. What is the ratio of the Population (in %) of Mexico in 1984 to that in 1987?
Provide a succinct answer. 0.96. What is the ratio of the Population (in %) in Suriname in 1984 to that in 1987?
Your answer should be very brief. 0.98. What is the ratio of the Population (in %) in Uzbekistan in 1984 to that in 1987?
Ensure brevity in your answer.  1.08. What is the ratio of the Population (in %) in Bahamas in 1984 to that in 1988?
Offer a very short reply. 0.99. What is the ratio of the Population (in %) of Mexico in 1984 to that in 1988?
Make the answer very short. 0.95. What is the ratio of the Population (in %) in Suriname in 1984 to that in 1988?
Make the answer very short. 0.97. What is the ratio of the Population (in %) in Uzbekistan in 1984 to that in 1988?
Give a very brief answer. 1.1. What is the ratio of the Population (in %) of Bahamas in 1985 to that in 1986?
Make the answer very short. 1. What is the ratio of the Population (in %) of Mexico in 1985 to that in 1986?
Your answer should be very brief. 0.99. What is the ratio of the Population (in %) of Suriname in 1985 to that in 1986?
Provide a succinct answer. 1. What is the ratio of the Population (in %) of Uzbekistan in 1985 to that in 1986?
Your answer should be compact. 1.03. What is the ratio of the Population (in %) in Mexico in 1985 to that in 1987?
Give a very brief answer. 0.97. What is the ratio of the Population (in %) in Suriname in 1985 to that in 1987?
Offer a very short reply. 0.99. What is the ratio of the Population (in %) in Uzbekistan in 1985 to that in 1987?
Your answer should be compact. 1.05. What is the ratio of the Population (in %) of Bahamas in 1985 to that in 1988?
Give a very brief answer. 0.99. What is the ratio of the Population (in %) of Mexico in 1985 to that in 1988?
Provide a succinct answer. 0.96. What is the ratio of the Population (in %) of Suriname in 1985 to that in 1988?
Make the answer very short. 0.98. What is the ratio of the Population (in %) of Uzbekistan in 1985 to that in 1988?
Provide a short and direct response. 1.07. What is the ratio of the Population (in %) of Bahamas in 1986 to that in 1987?
Give a very brief answer. 1. What is the ratio of the Population (in %) of Mexico in 1986 to that in 1987?
Offer a terse response. 0.98. What is the ratio of the Population (in %) of Uzbekistan in 1986 to that in 1987?
Offer a very short reply. 1.02. What is the ratio of the Population (in %) of Bahamas in 1986 to that in 1988?
Offer a very short reply. 0.99. What is the ratio of the Population (in %) in Mexico in 1986 to that in 1988?
Give a very brief answer. 0.97. What is the ratio of the Population (in %) of Suriname in 1986 to that in 1988?
Your response must be concise. 0.98. What is the ratio of the Population (in %) of Uzbekistan in 1986 to that in 1988?
Provide a short and direct response. 1.05. What is the ratio of the Population (in %) in Bahamas in 1987 to that in 1988?
Offer a very short reply. 0.99. What is the ratio of the Population (in %) in Mexico in 1987 to that in 1988?
Give a very brief answer. 0.98. What is the ratio of the Population (in %) in Suriname in 1987 to that in 1988?
Offer a very short reply. 0.99. What is the ratio of the Population (in %) of Uzbekistan in 1987 to that in 1988?
Give a very brief answer. 1.02. What is the difference between the highest and the second highest Population (in %) of Bahamas?
Offer a terse response. 0.03. What is the difference between the highest and the second highest Population (in %) in Mexico?
Provide a succinct answer. 0.07. What is the difference between the highest and the second highest Population (in %) of Suriname?
Offer a very short reply. 0.05. What is the difference between the highest and the second highest Population (in %) in Uzbekistan?
Your answer should be compact. 0.15. What is the difference between the highest and the lowest Population (in %) of Bahamas?
Offer a terse response. 0.05. What is the difference between the highest and the lowest Population (in %) of Mexico?
Provide a short and direct response. 0.24. What is the difference between the highest and the lowest Population (in %) of Suriname?
Provide a succinct answer. 0.19. What is the difference between the highest and the lowest Population (in %) of Uzbekistan?
Provide a succinct answer. 0.86. 